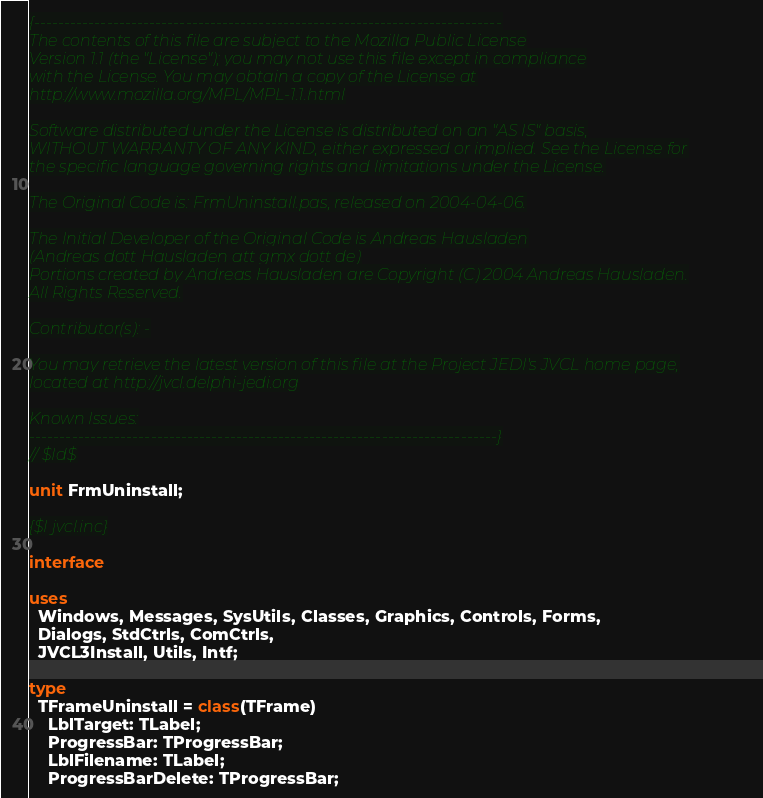<code> <loc_0><loc_0><loc_500><loc_500><_Pascal_>{-----------------------------------------------------------------------------
The contents of this file are subject to the Mozilla Public License
Version 1.1 (the "License"); you may not use this file except in compliance
with the License. You may obtain a copy of the License at
http://www.mozilla.org/MPL/MPL-1.1.html

Software distributed under the License is distributed on an "AS IS" basis,
WITHOUT WARRANTY OF ANY KIND, either expressed or implied. See the License for
the specific language governing rights and limitations under the License.

The Original Code is: FrmUninstall.pas, released on 2004-04-06.

The Initial Developer of the Original Code is Andreas Hausladen
(Andreas dott Hausladen att gmx dott de)
Portions created by Andreas Hausladen are Copyright (C) 2004 Andreas Hausladen.
All Rights Reserved.

Contributor(s): -

You may retrieve the latest version of this file at the Project JEDI's JVCL home page,
located at http://jvcl.delphi-jedi.org

Known Issues:
-----------------------------------------------------------------------------}
// $Id$

unit FrmUninstall;

{$I jvcl.inc}

interface

uses
  Windows, Messages, SysUtils, Classes, Graphics, Controls, Forms,
  Dialogs, StdCtrls, ComCtrls,
  JVCL3Install, Utils, Intf;

type
  TFrameUninstall = class(TFrame)
    LblTarget: TLabel;
    ProgressBar: TProgressBar;
    LblFilename: TLabel;
    ProgressBarDelete: TProgressBar;</code> 